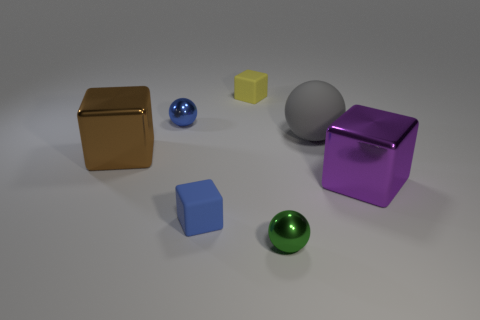Subtract all tiny blue blocks. How many blocks are left? 3 Subtract 1 blocks. How many blocks are left? 3 Add 2 tiny blue shiny spheres. How many objects exist? 9 Add 6 small blue metallic balls. How many small blue metallic balls are left? 7 Add 5 yellow metallic blocks. How many yellow metallic blocks exist? 5 Subtract all brown cubes. How many cubes are left? 3 Subtract 0 red cylinders. How many objects are left? 7 Subtract all blocks. How many objects are left? 3 Subtract all purple spheres. Subtract all green cubes. How many spheres are left? 3 Subtract all cyan cylinders. How many cyan balls are left? 0 